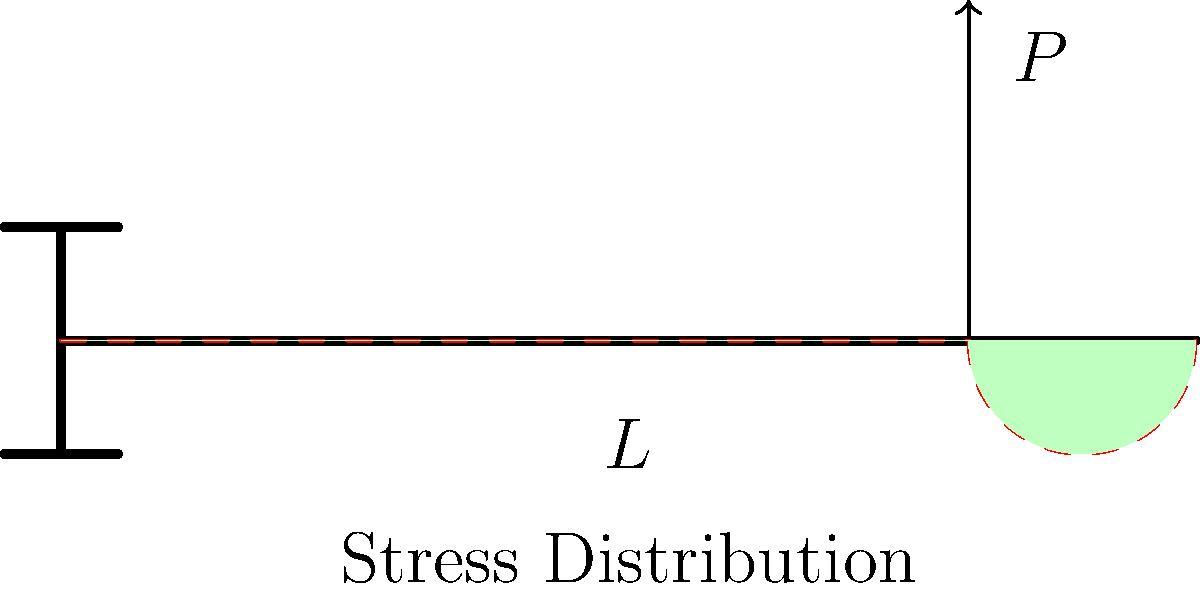In a cantilever beam of length $L$ with a point load $P$ applied at a distance $0.8L$ from the fixed end, how does the bending stress distribution vary along the length of the beam? Describe the shape and magnitude of the stress at key points. To understand the stress distribution in this cantilever beam, let's follow these steps:

1. Cantilever beam configuration:
   - The beam is fixed at one end (left) and free at the other end (right).
   - A point load $P$ is applied at $0.8L$ from the fixed end.

2. Bending moment distribution:
   - The bending moment is maximum at the fixed end and decreases linearly to zero at the point of load application.
   - From the point of load to the free end, the bending moment remains zero.

3. Stress-moment relationship:
   - Bending stress is directly proportional to the bending moment: $\sigma = \frac{My}{I}$
   where $M$ is the bending moment, $y$ is the distance from the neutral axis, and $I$ is the moment of inertia.

4. Stress distribution along the beam:
   a) At the fixed end (x = 0):
      - Maximum bending stress occurs here.
      - Stress varies linearly from maximum tension at the top to maximum compression at the bottom.

   b) From fixed end to point of load (0 < x < 0.8L):
      - Stress decreases linearly with distance from the fixed end.
      - At each cross-section, stress varies linearly from tension to compression.

   c) At the point of load (x = 0.8L):
      - Stress is non-zero but smaller than at the fixed end.
      - Stress still varies linearly across the cross-section.

   d) From point of load to free end (0.8L < x ≤ L):
      - Zero bending stress as there is no bending moment in this region.

5. Shape of stress distribution:
   - The overall shape resembles a triangle with its base at the fixed end and apex at the point of load application.
   - Beyond the point of load, the stress is zero.

6. Key points:
   - Maximum stress: At the fixed end, top and bottom fibers
   - Zero stress: At the neutral axis along the entire beam and throughout the cross-section from the point of load to the free end
Answer: Triangular distribution with maximum at fixed end, decreasing linearly to point load, then zero to free end. 